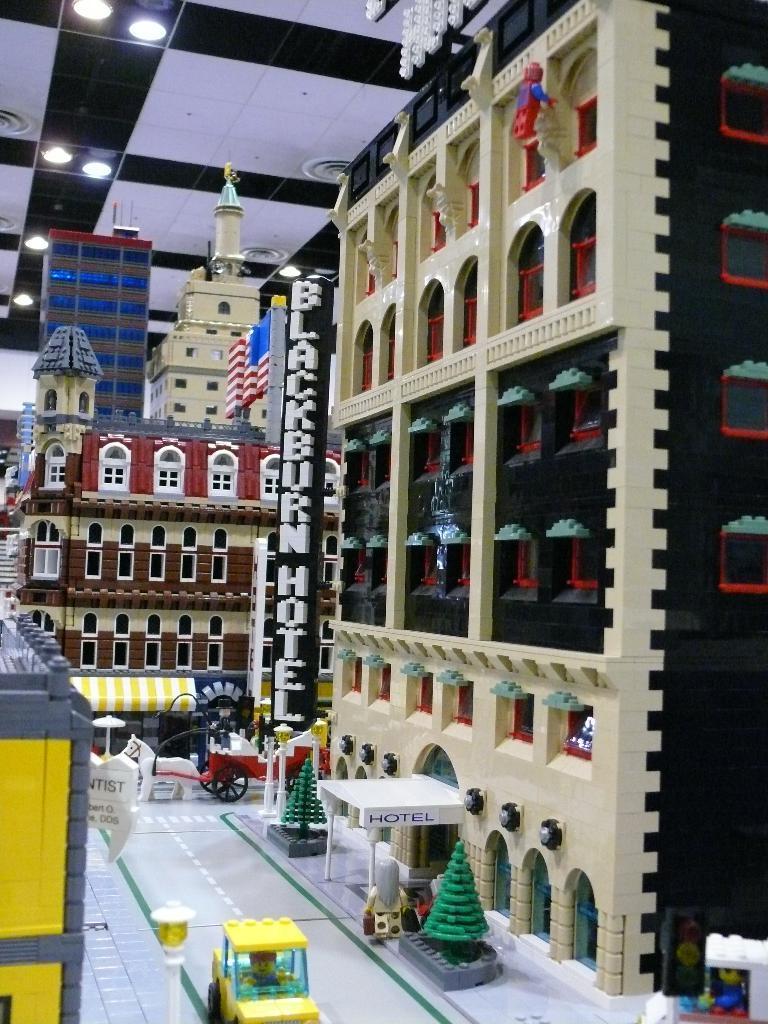Describe this image in one or two sentences. In this image we can see the Lego. Here I can see few toy buildings. At the bottom there are few toy vehicles and trees. At the top of the image there are few lights to the roof. 